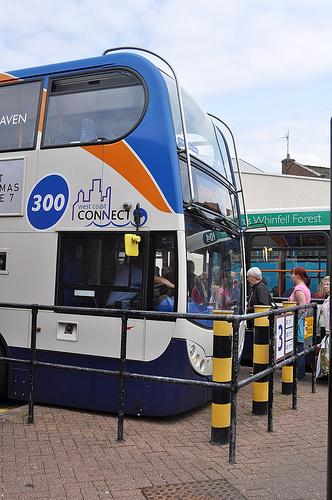Describe the condition of the sky in the image. The sky appears to be cloudy. Mention the primary mode of transportation in the image and its state. A parked double-decker tour bus is seen loading passengers. What is the surface of the sidewalk in the image made of? The sidewalk appears to be made of cobblestone. What object is found on the top of the bus, and what color is it? Yellow driver-side mirror is located at the top of the bus. What is one notable number on the bus, and which color is it? The number 300 is in a blue circle on the side of the bus. Point out the color of a woman's hair and her clothing in the image. A red-haired woman is wearing a pink shirt. Mention the two colors of the poles in front of the bus. The poles in front of the bus are black and yellow. Describe the appearance of the woman with white hair. The woman with white hair is wearing a black jacket. Identify the central object in the picture and describe its colors. The large bus in the image is blue, white, and orange. Mention an object on a nearby building and describe its color. There is a green sign on a nearby building. 